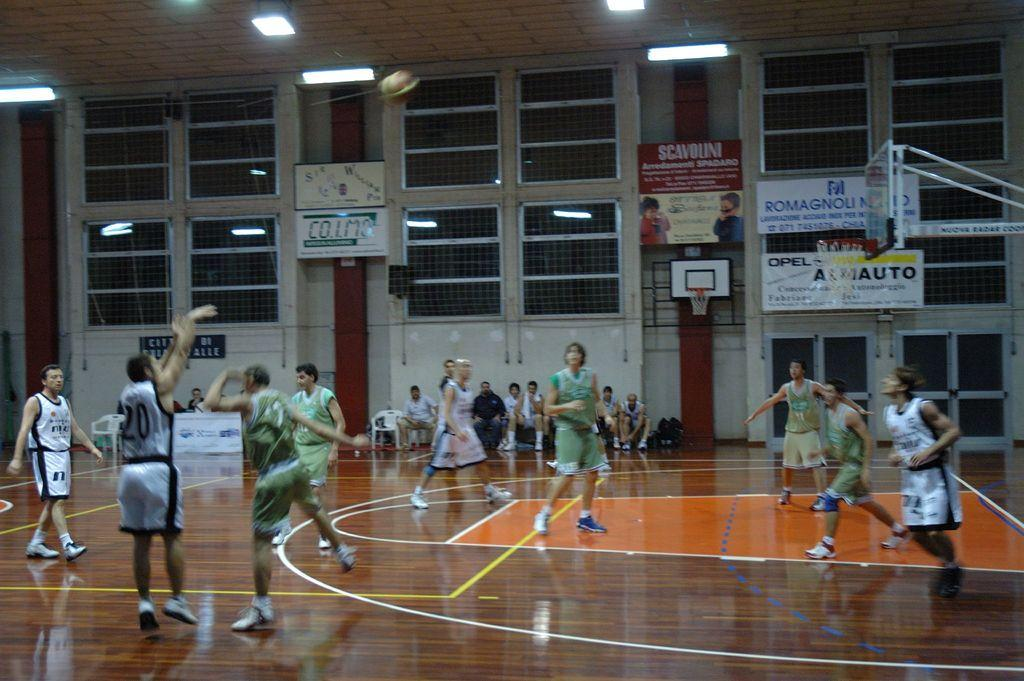<image>
Share a concise interpretation of the image provided. A basketball court with a man with the number twenty on his jersey 